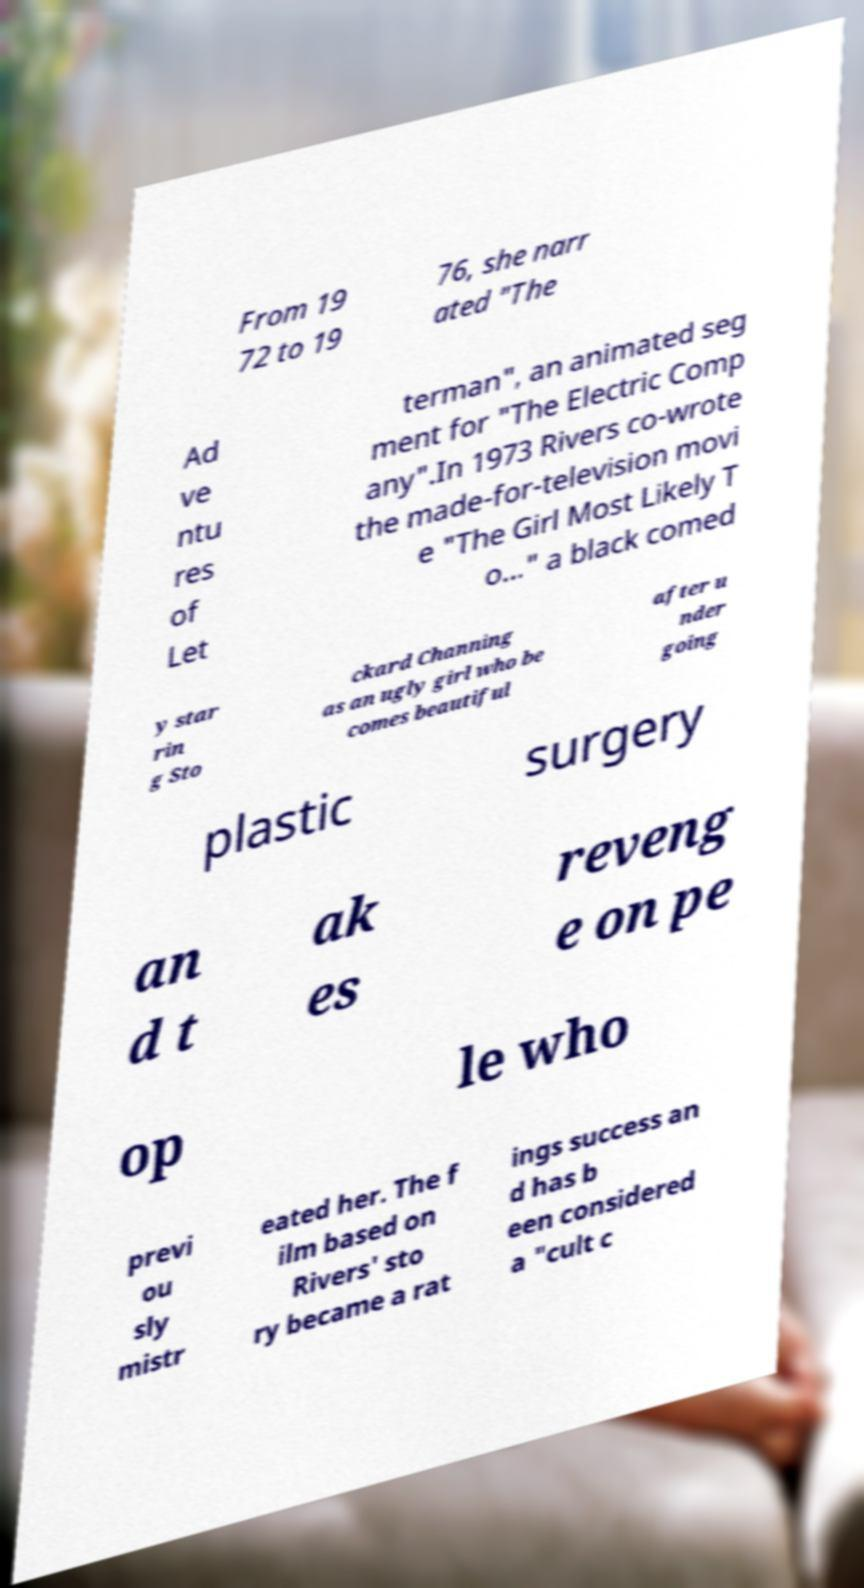Please read and relay the text visible in this image. What does it say? From 19 72 to 19 76, she narr ated "The Ad ve ntu res of Let terman", an animated seg ment for "The Electric Comp any".In 1973 Rivers co-wrote the made-for-television movi e "The Girl Most Likely T o..." a black comed y star rin g Sto ckard Channing as an ugly girl who be comes beautiful after u nder going plastic surgery an d t ak es reveng e on pe op le who previ ou sly mistr eated her. The f ilm based on Rivers' sto ry became a rat ings success an d has b een considered a "cult c 